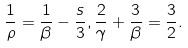Convert formula to latex. <formula><loc_0><loc_0><loc_500><loc_500>\frac { 1 } { \rho } = \frac { 1 } { \beta } - \frac { s } { 3 } , \frac { 2 } { \gamma } + \frac { 3 } { \beta } = \frac { 3 } { 2 } .</formula> 